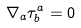Convert formula to latex. <formula><loc_0><loc_0><loc_500><loc_500>\nabla _ { a } \tau ^ { a } _ { b } = 0</formula> 